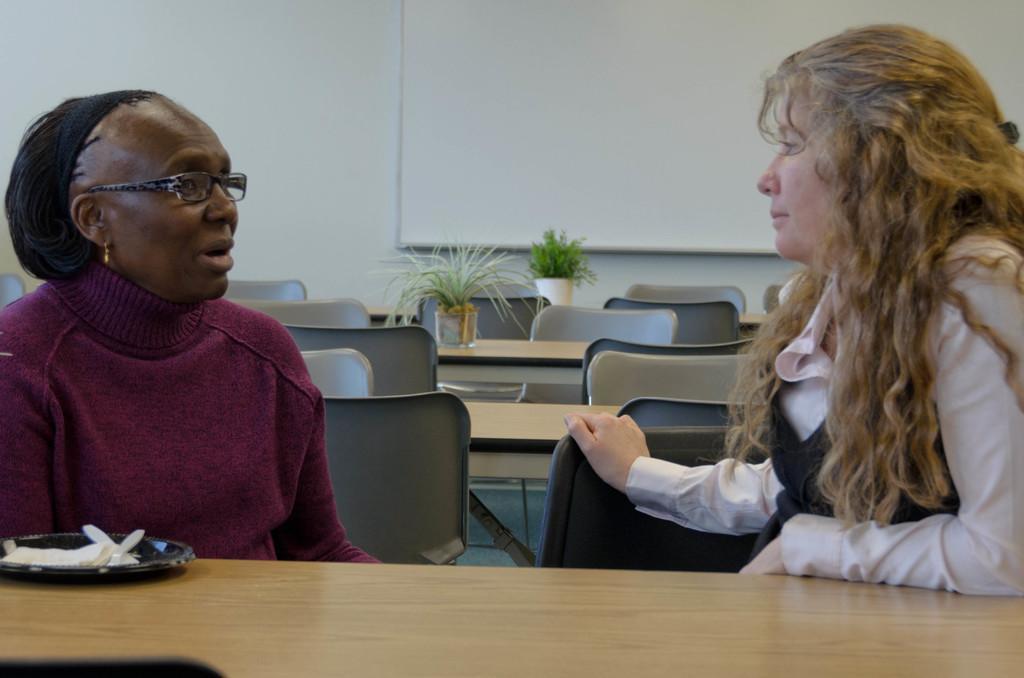Could you give a brief overview of what you see in this image? In this picture there are two women, one of them is speaking and other is looking at the one who is speaking. 